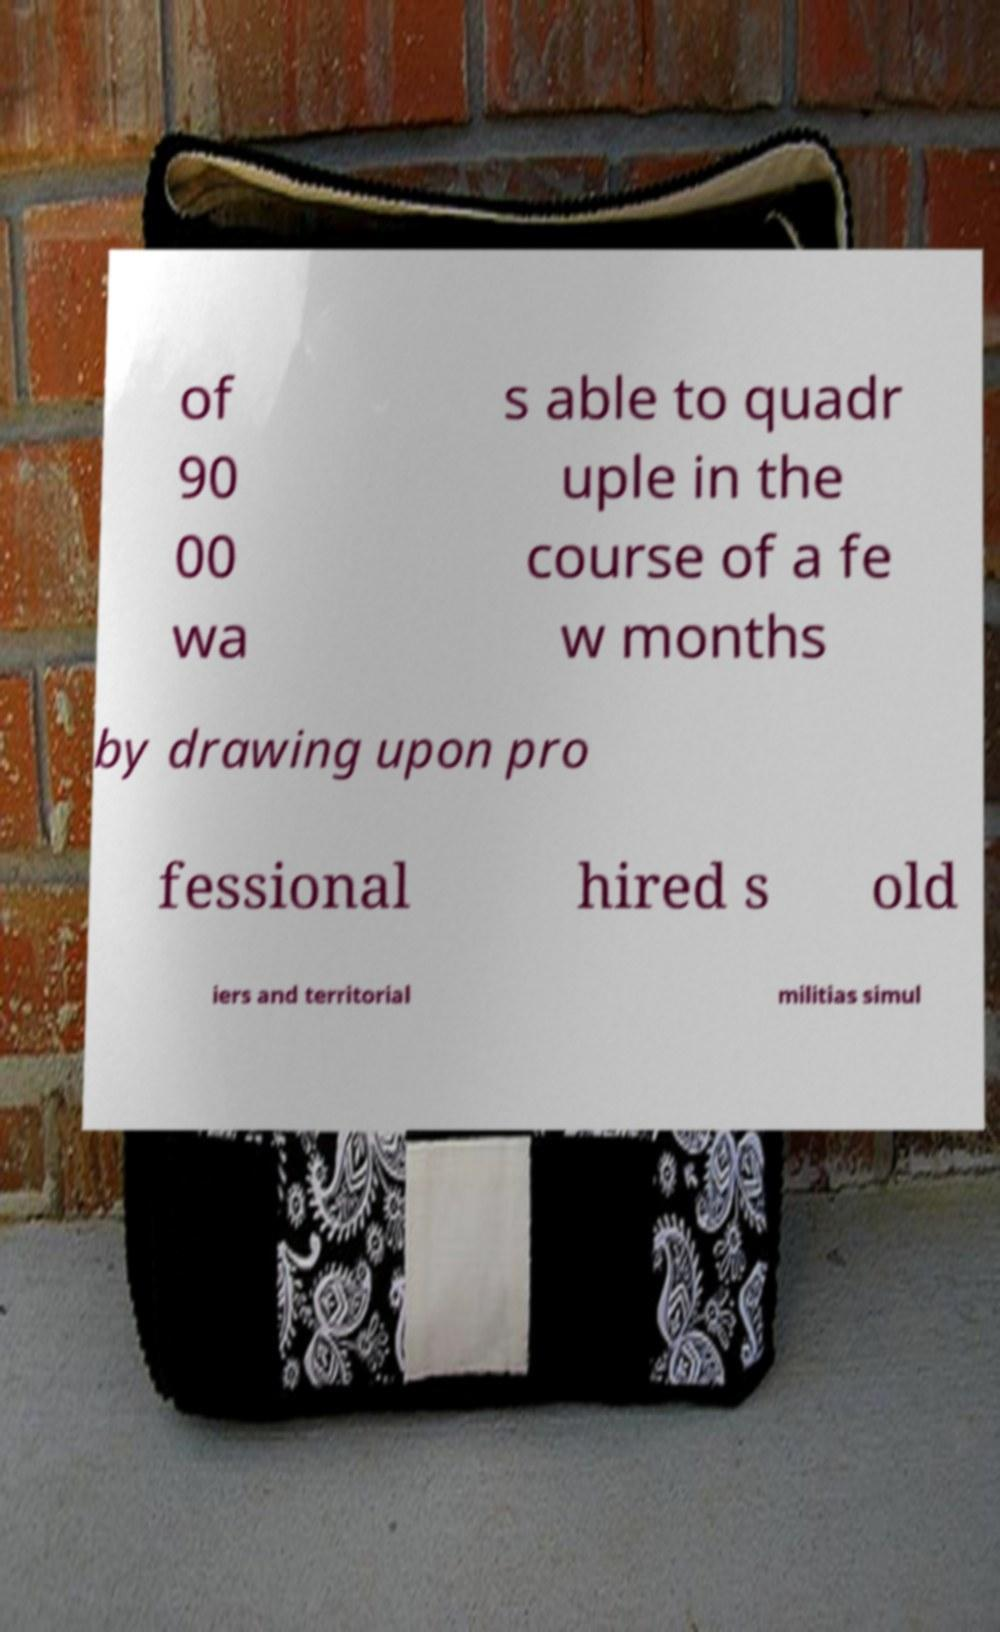For documentation purposes, I need the text within this image transcribed. Could you provide that? of 90 00 wa s able to quadr uple in the course of a fe w months by drawing upon pro fessional hired s old iers and territorial militias simul 